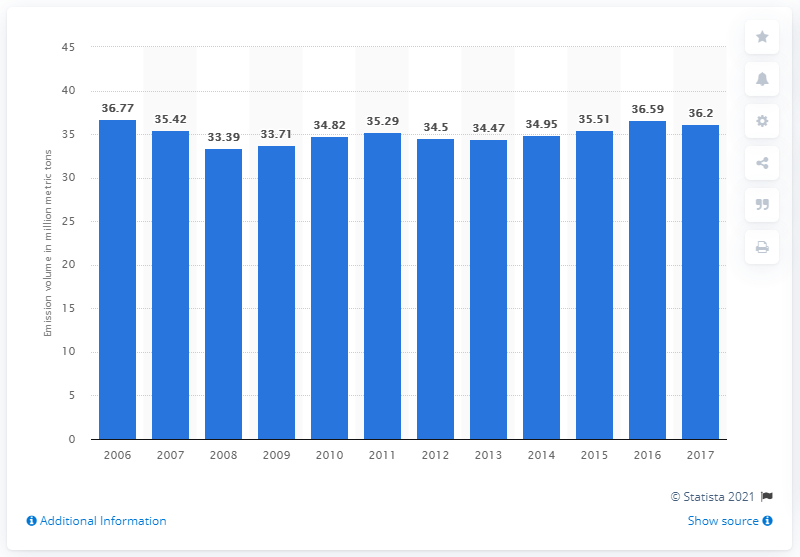Outline some significant characteristics in this image. The transportation sector in Taiwan emitted 36.2 million metric tons of CO2 in 2017. 